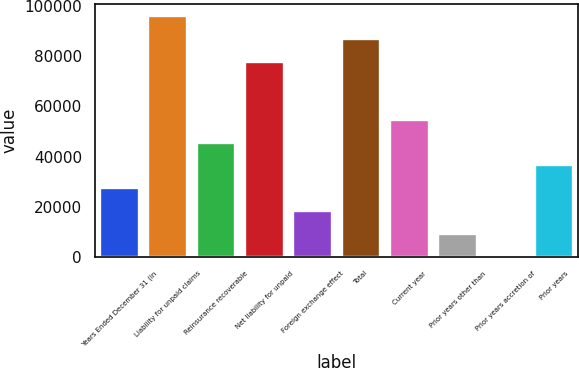Convert chart to OTSL. <chart><loc_0><loc_0><loc_500><loc_500><bar_chart><fcel>Years Ended December 31 (in<fcel>Liability for unpaid claims<fcel>Reinsurance recoverable<fcel>Net liability for unpaid<fcel>Foreign exchange effect<fcel>Total<fcel>Current year<fcel>Prior years other than<fcel>Prior years accretion of<fcel>Prior years<nl><fcel>27387.6<fcel>96106.6<fcel>45604<fcel>77890.2<fcel>18279.4<fcel>86998.4<fcel>54712.2<fcel>9171.2<fcel>63<fcel>36495.8<nl></chart> 